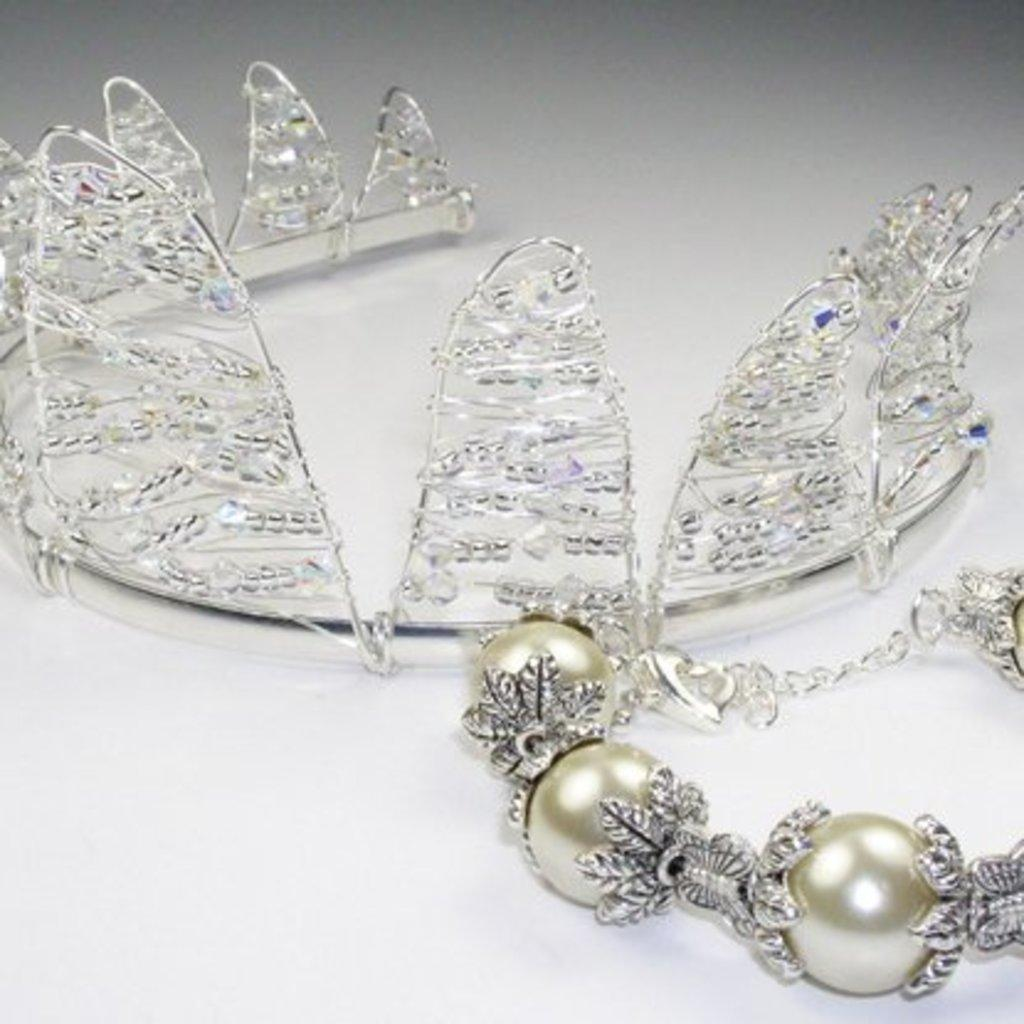What type of accessory is present in the image? There is a bracelet in the image. What other item can be seen in the image? There is a crown in the image. What type of texture can be seen on the shoes in the image? There are no shoes present in the image; it only features a bracelet and a crown. 